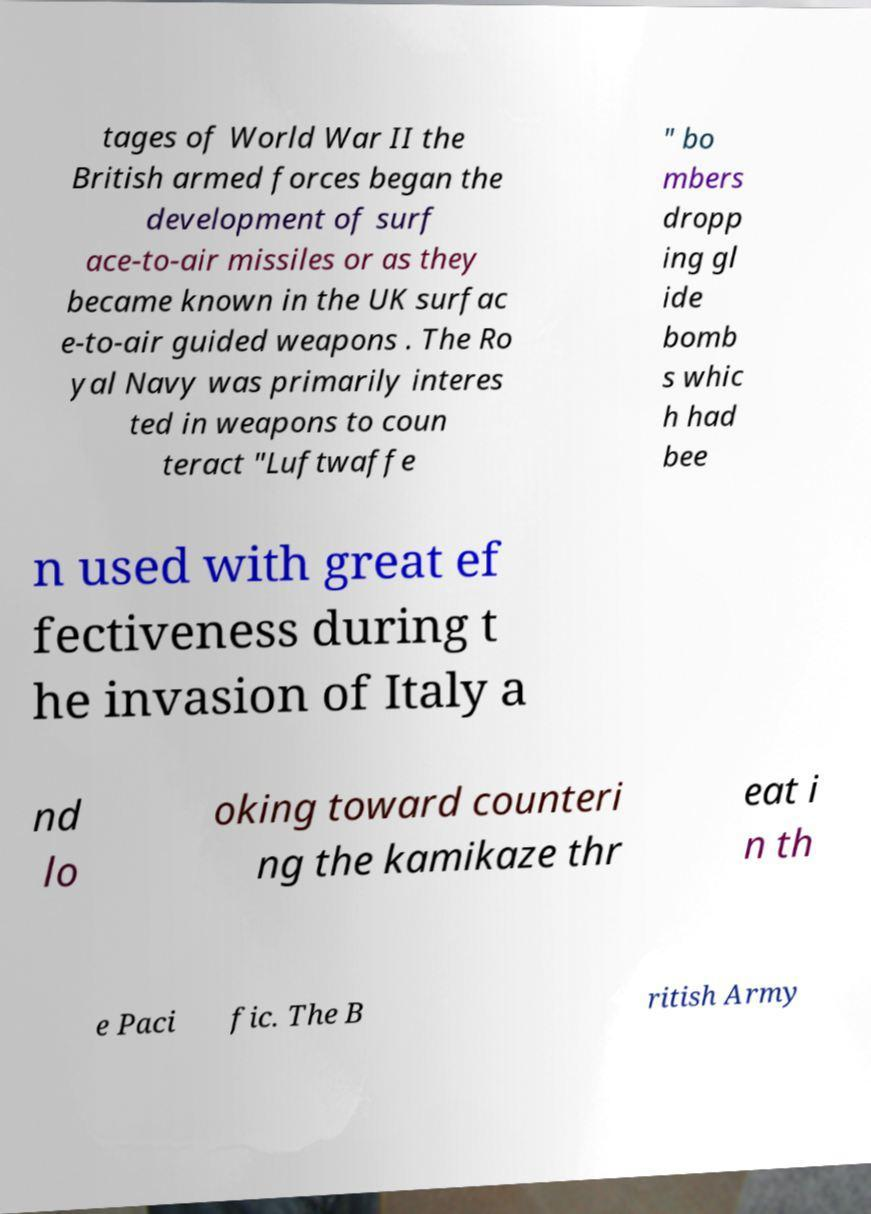For documentation purposes, I need the text within this image transcribed. Could you provide that? tages of World War II the British armed forces began the development of surf ace-to-air missiles or as they became known in the UK surfac e-to-air guided weapons . The Ro yal Navy was primarily interes ted in weapons to coun teract "Luftwaffe " bo mbers dropp ing gl ide bomb s whic h had bee n used with great ef fectiveness during t he invasion of Italy a nd lo oking toward counteri ng the kamikaze thr eat i n th e Paci fic. The B ritish Army 